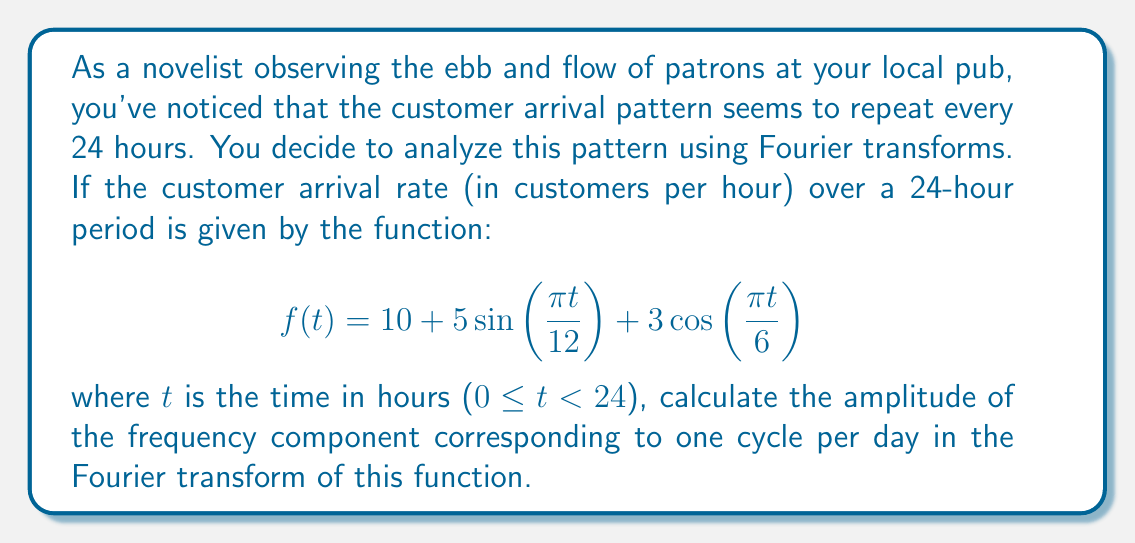Provide a solution to this math problem. To solve this problem, we'll follow these steps:

1) First, let's identify the frequencies in the given function:
   $$f(t) = 10 + 5\sin(\frac{\pi t}{12}) + 3\cos(\frac{\pi t}{6})$$

   The sine term has a period of 24 hours (one cycle per day)
   The cosine term has a period of 12 hours (two cycles per day)

2) The Fourier transform will have components at these frequencies. We're interested in the component with frequency $\omega = \frac{2\pi}{24} = \frac{\pi}{12}$ rad/hour, which corresponds to one cycle per day.

3) In the Fourier transform, this component will have contributions from both the sine and cosine terms in the original function that have this frequency.

4) The amplitude of a frequency component in a Fourier transform is given by the square root of the sum of squares of its sine and cosine coefficients.

5) In our function:
   - The sine term with frequency $\frac{\pi}{12}$ has a coefficient of 5
   - The cosine term with frequency $\frac{\pi}{12}$ has a coefficient of 0 (it's not present in the original function)

6) Therefore, the amplitude $A$ of the frequency component corresponding to one cycle per day is:

   $$A = \sqrt{5^2 + 0^2} = 5$$
Answer: The amplitude of the frequency component corresponding to one cycle per day in the Fourier transform is 5. 